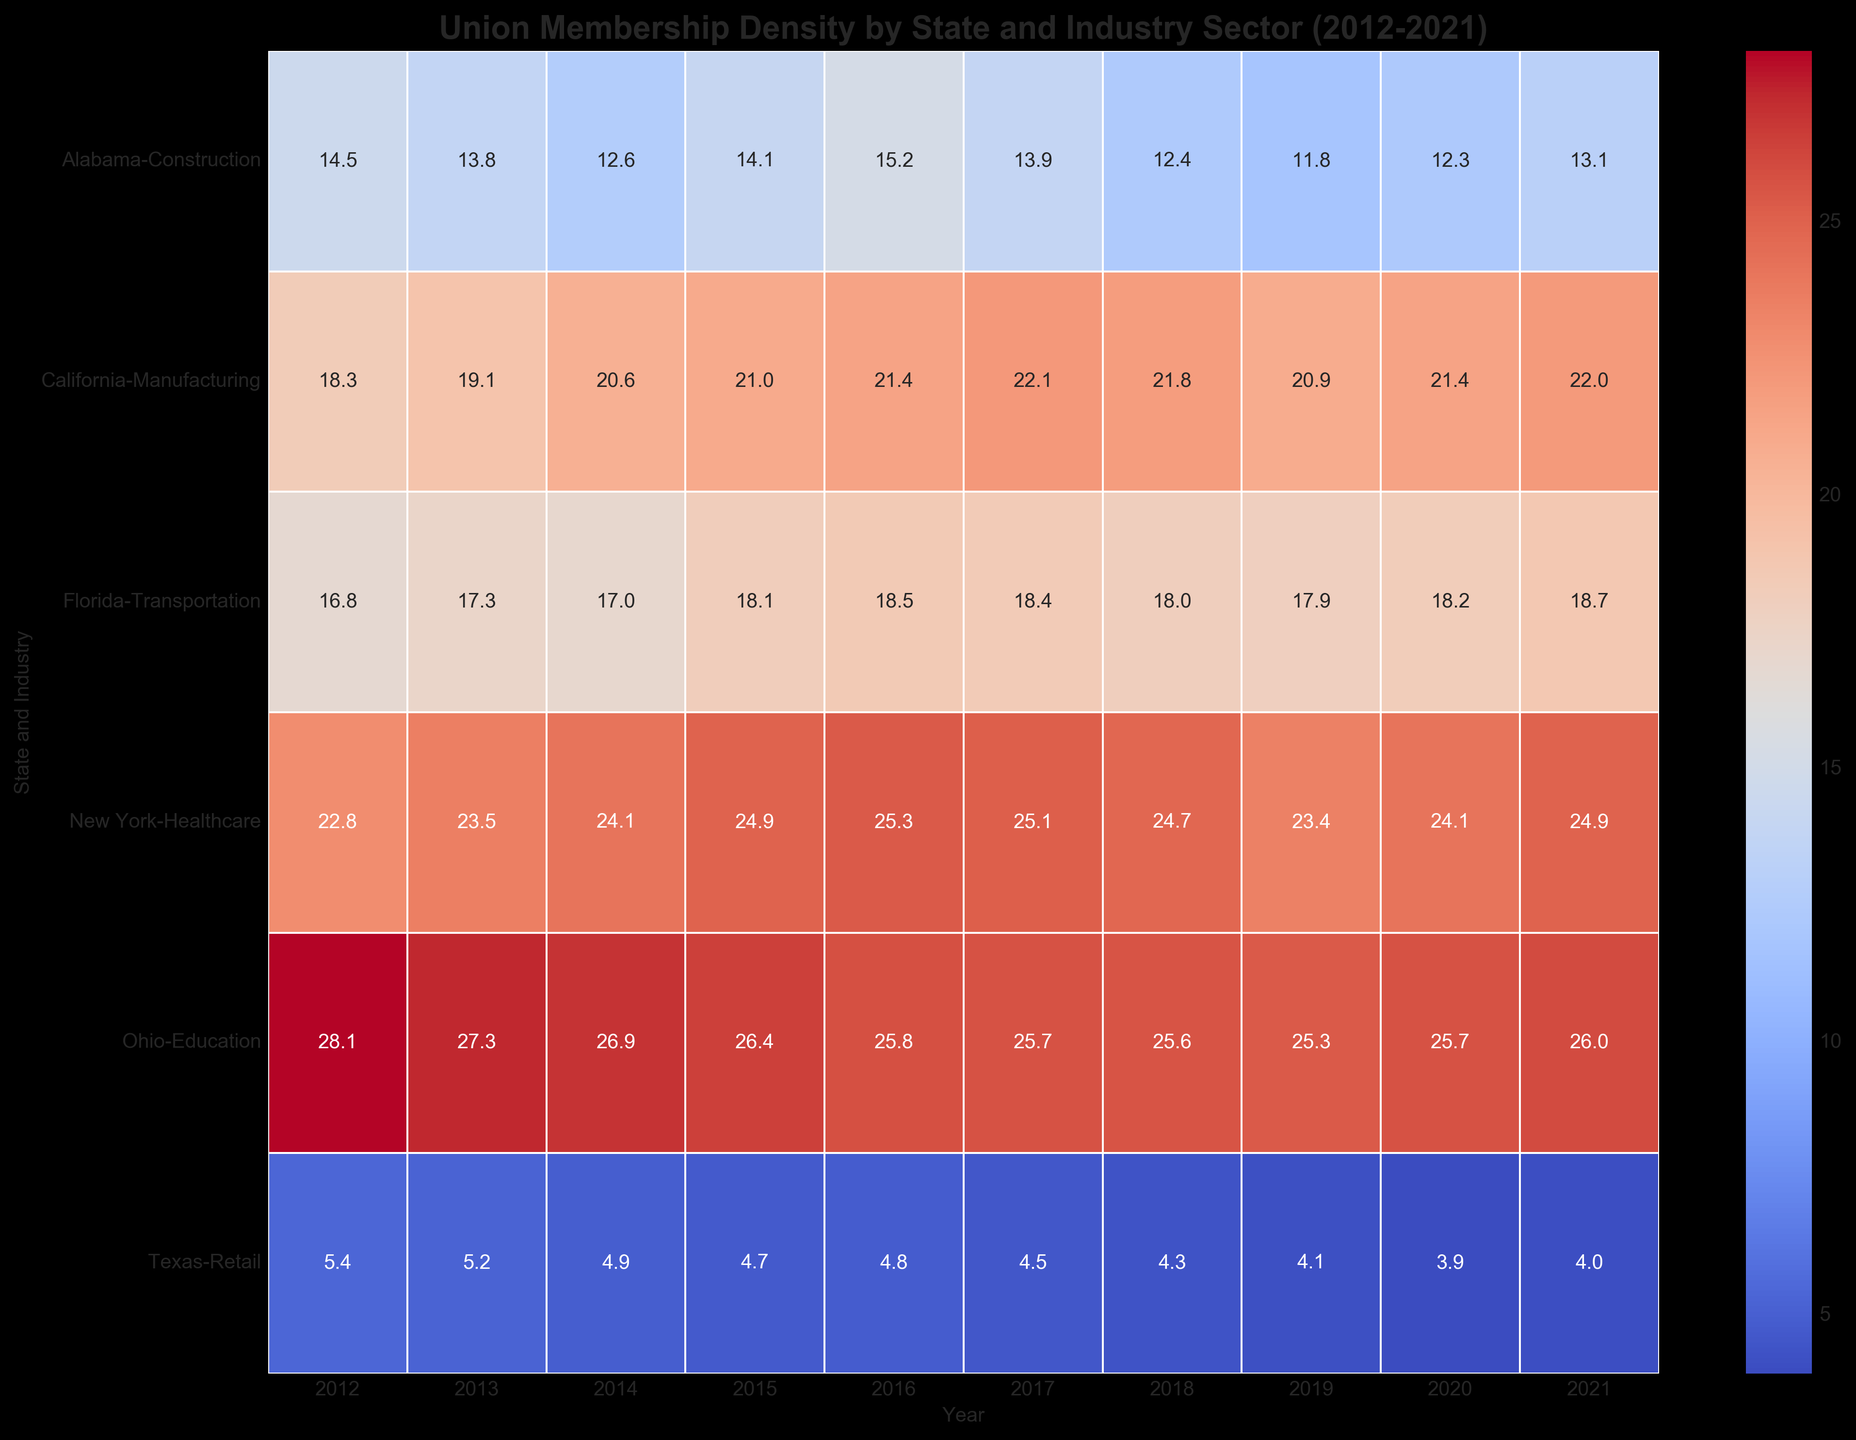What's the trend in union membership density in Ohio's Education sector from 2012 to 2021? To determine the trend, we examine the yearly values in Ohio's Education sector: 28.1 (2012), 27.3 (2013), 26.9 (2014), 26.4 (2015), 25.8 (2016), 25.7 (2017), 25.6 (2018), 25.3 (2019), 25.7 (2020), and 26.0 (2021). The overall trend is a decrease from 2012 to 2021, though there are slight fluctuations.
Answer: Decreasing trend Which state and sector had the highest union membership density in 2021? To answer this, look at the highest value under the 2021 column in the heatmap. New York Healthcare had a value of 24.9, which is higher than any other entry for 2021.
Answer: New York Healthcare How did the union membership density in Texas' Retail sector change from 2012 to 2021? We compare the values for Texas Retail from 2012 to 2021: 5.4 (2012), 5.2 (2013), 4.9 (2014), 4.7 (2015), 4.8 (2016), 4.5 (2017), 4.3 (2018), 4.1 (2019), 3.9 (2020), and 4.0 (2021). There is a clear decrease, although a slight uptick in 2021.
Answer: Decreased overall Which sector in California saw the most consistent increase in union membership density over the decade? We examine the values for California Manufacturing: 18.3 (2012), 19.1 (2013), 20.6 (2014), 21.0 (2015), 21.4 (2016), 22.1 (2017), 21.8 (2018), 20.9 (2019), 21.4 (2020), and 22.0 (2021). The union density consistently increased over the decade, despite a slight dip in 2019 and 2020.
Answer: Manufacturing What is the average union membership density across all sectors in Florida in 2021? Florida's Transportation sector in 2021: 18.7. Since there's only one sector, the average is the same as the density.
Answer: 18.7 Compare the union membership density in Alabama Construction in 2016 and New York Healthcare in 2016. Which had a higher density? Alabama Construction in 2016 is 15.2, while New York Healthcare in 2016 is 25.3. New York Healthcare had a higher density.
Answer: New York Healthcare What visual pattern do you observe in the heatmap for states with increasing union membership density? In the heatmap, states/sectors with increasing union membership density generally trend towards cooler to warmer colors (lighter shades to darker shades of red) as we move from left (2012) to right (2021).
Answer: Cooler to warmer colors (left to right) 